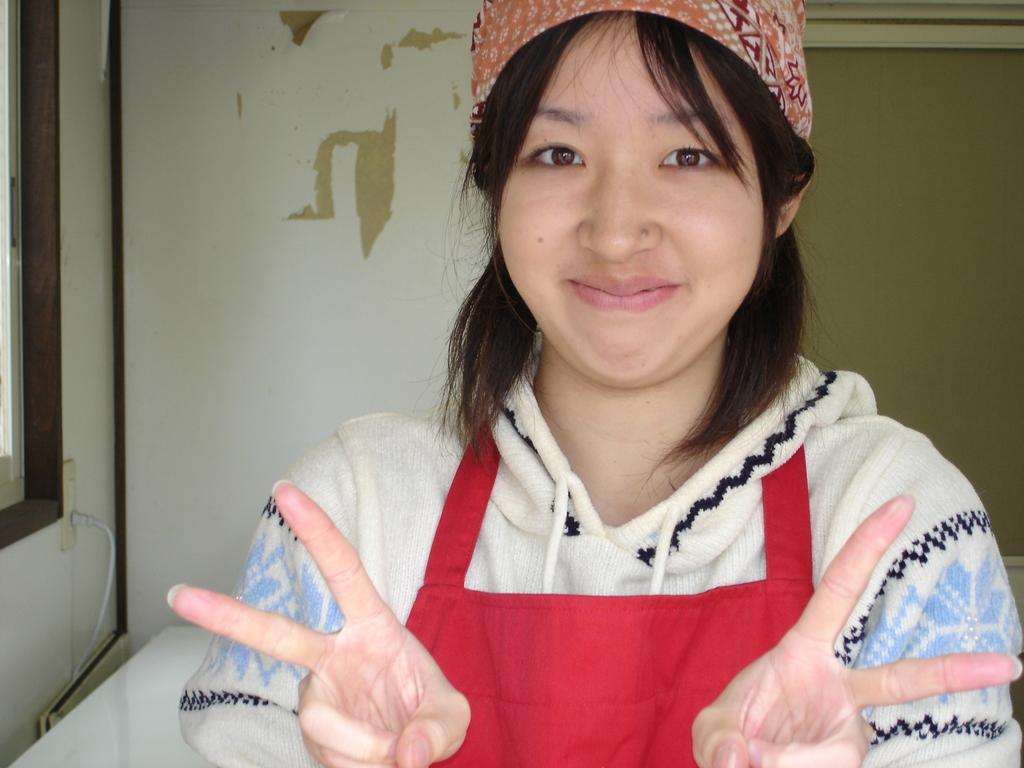Can you describe this image briefly? In this picture I can see a woman is standing. The woman is smiling. The woman is wearing red color apron, a cap and a white color dress. In the background I can see a white color wall. 